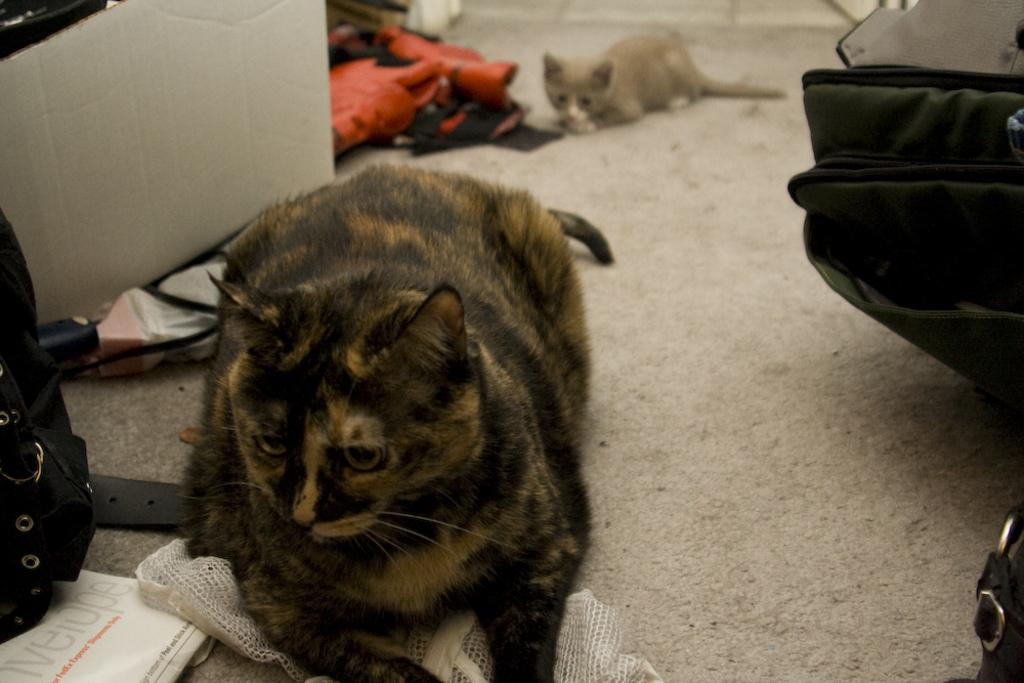What is located on the right side of the image? There is a backpack on the right side of the image. What is the main subject in the center of the image? There is a cat in the center of the image. What other items can be seen on the left side of the image? There is another backpack, a box, a belt, a book, and other objects on the left side of the image. Can you describe the background of the image? There is a cat visible in the background of the image. What position does the manager hold in the image? There is no manager present in the image. What type of room is depicted in the image? The image does not depict a room; it shows various objects and a cat. 